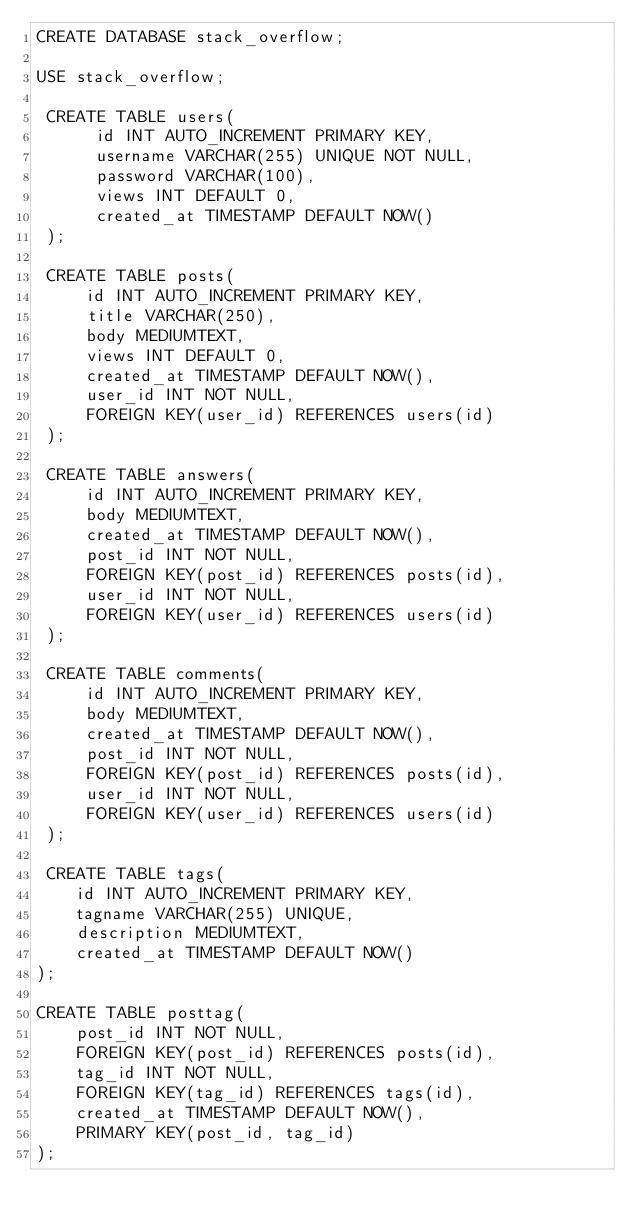<code> <loc_0><loc_0><loc_500><loc_500><_SQL_>CREATE DATABASE stack_overflow;

USE stack_overflow;

 CREATE TABLE users(
      id INT AUTO_INCREMENT PRIMARY KEY,
      username VARCHAR(255) UNIQUE NOT NULL,
      password VARCHAR(100),
      views INT DEFAULT 0,
      created_at TIMESTAMP DEFAULT NOW()
 );

 CREATE TABLE posts(
     id INT AUTO_INCREMENT PRIMARY KEY,
     title VARCHAR(250),
     body MEDIUMTEXT,
     views INT DEFAULT 0,
     created_at TIMESTAMP DEFAULT NOW(),
     user_id INT NOT NULL,
     FOREIGN KEY(user_id) REFERENCES users(id)
 );

 CREATE TABLE answers(
     id INT AUTO_INCREMENT PRIMARY KEY,
     body MEDIUMTEXT,
     created_at TIMESTAMP DEFAULT NOW(),
     post_id INT NOT NULL,
     FOREIGN KEY(post_id) REFERENCES posts(id),
     user_id INT NOT NULL,
     FOREIGN KEY(user_id) REFERENCES users(id)
 );

 CREATE TABLE comments(
     id INT AUTO_INCREMENT PRIMARY KEY,
     body MEDIUMTEXT,
     created_at TIMESTAMP DEFAULT NOW(),
     post_id INT NOT NULL,
     FOREIGN KEY(post_id) REFERENCES posts(id),
     user_id INT NOT NULL,
     FOREIGN KEY(user_id) REFERENCES users(id)
 );

 CREATE TABLE tags(
    id INT AUTO_INCREMENT PRIMARY KEY,
    tagname VARCHAR(255) UNIQUE,
    description MEDIUMTEXT,
    created_at TIMESTAMP DEFAULT NOW()
);

CREATE TABLE posttag(
    post_id INT NOT NULL,
    FOREIGN KEY(post_id) REFERENCES posts(id),
    tag_id INT NOT NULL,
    FOREIGN KEY(tag_id) REFERENCES tags(id),
    created_at TIMESTAMP DEFAULT NOW(),
    PRIMARY KEY(post_id, tag_id)
);</code> 